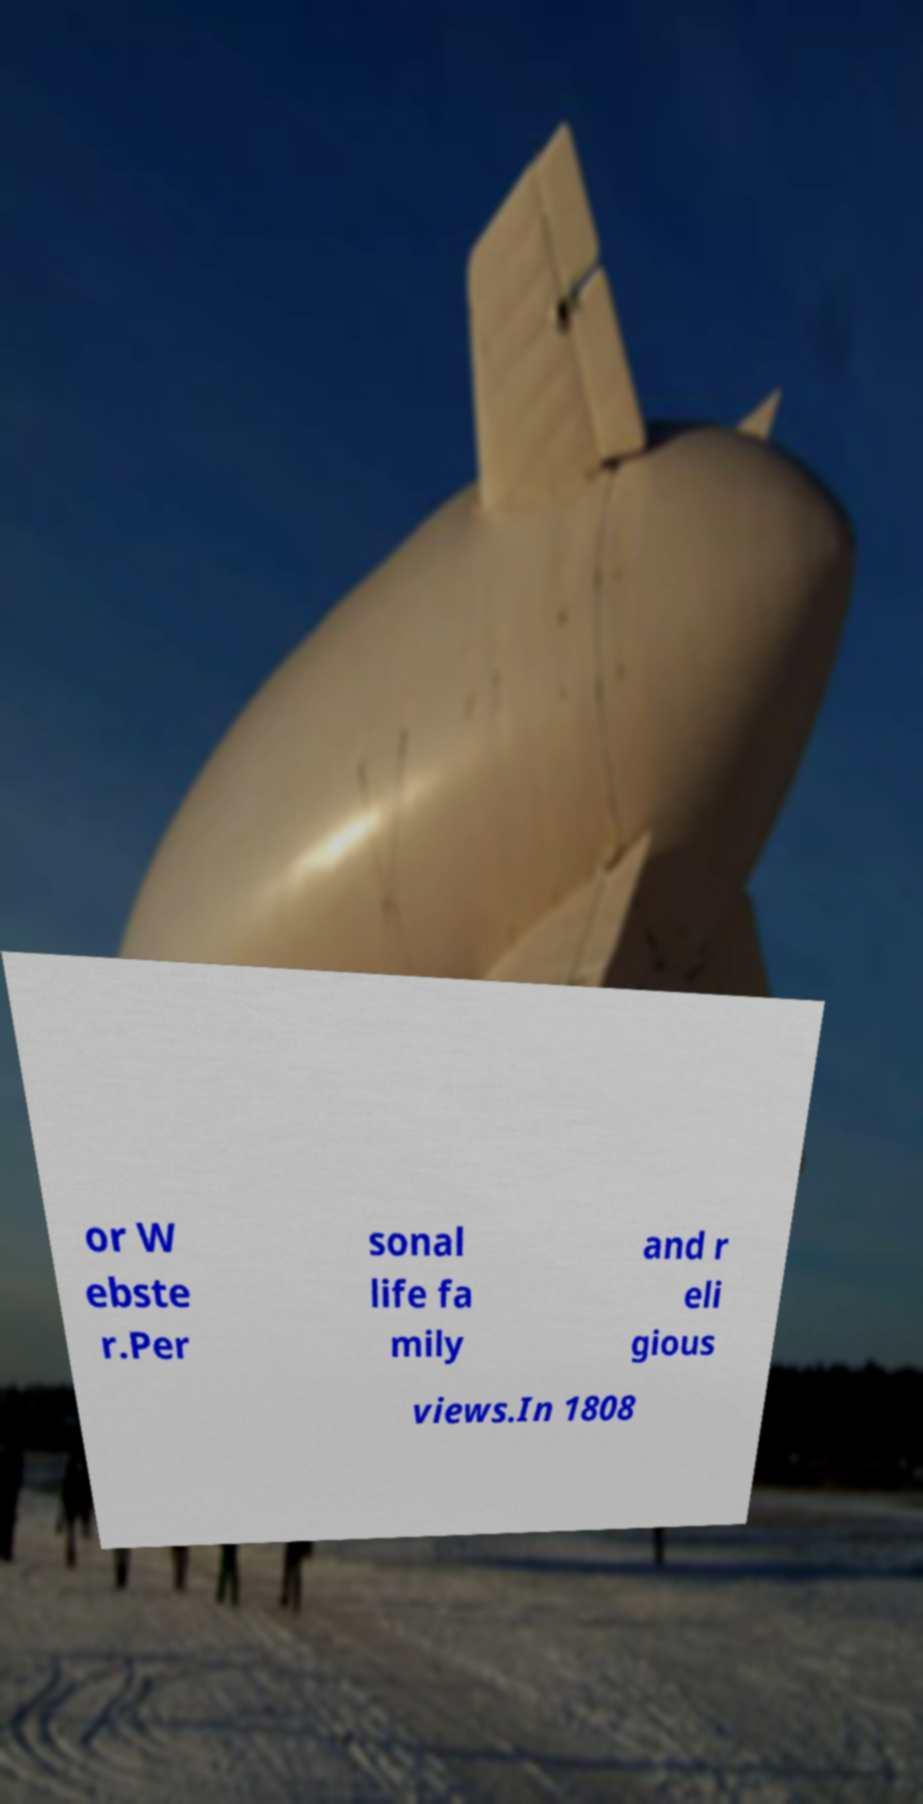Can you read and provide the text displayed in the image?This photo seems to have some interesting text. Can you extract and type it out for me? or W ebste r.Per sonal life fa mily and r eli gious views.In 1808 